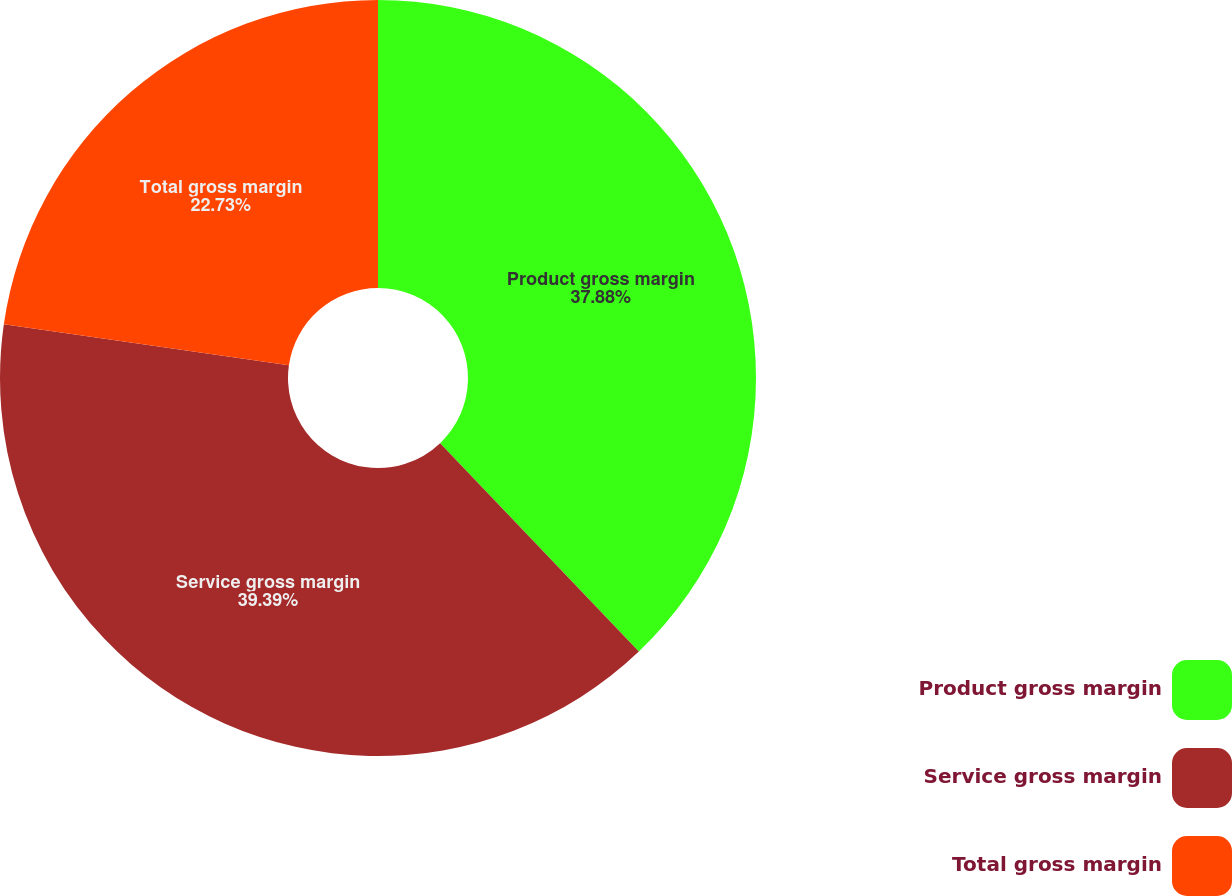Convert chart. <chart><loc_0><loc_0><loc_500><loc_500><pie_chart><fcel>Product gross margin<fcel>Service gross margin<fcel>Total gross margin<nl><fcel>37.88%<fcel>39.39%<fcel>22.73%<nl></chart> 